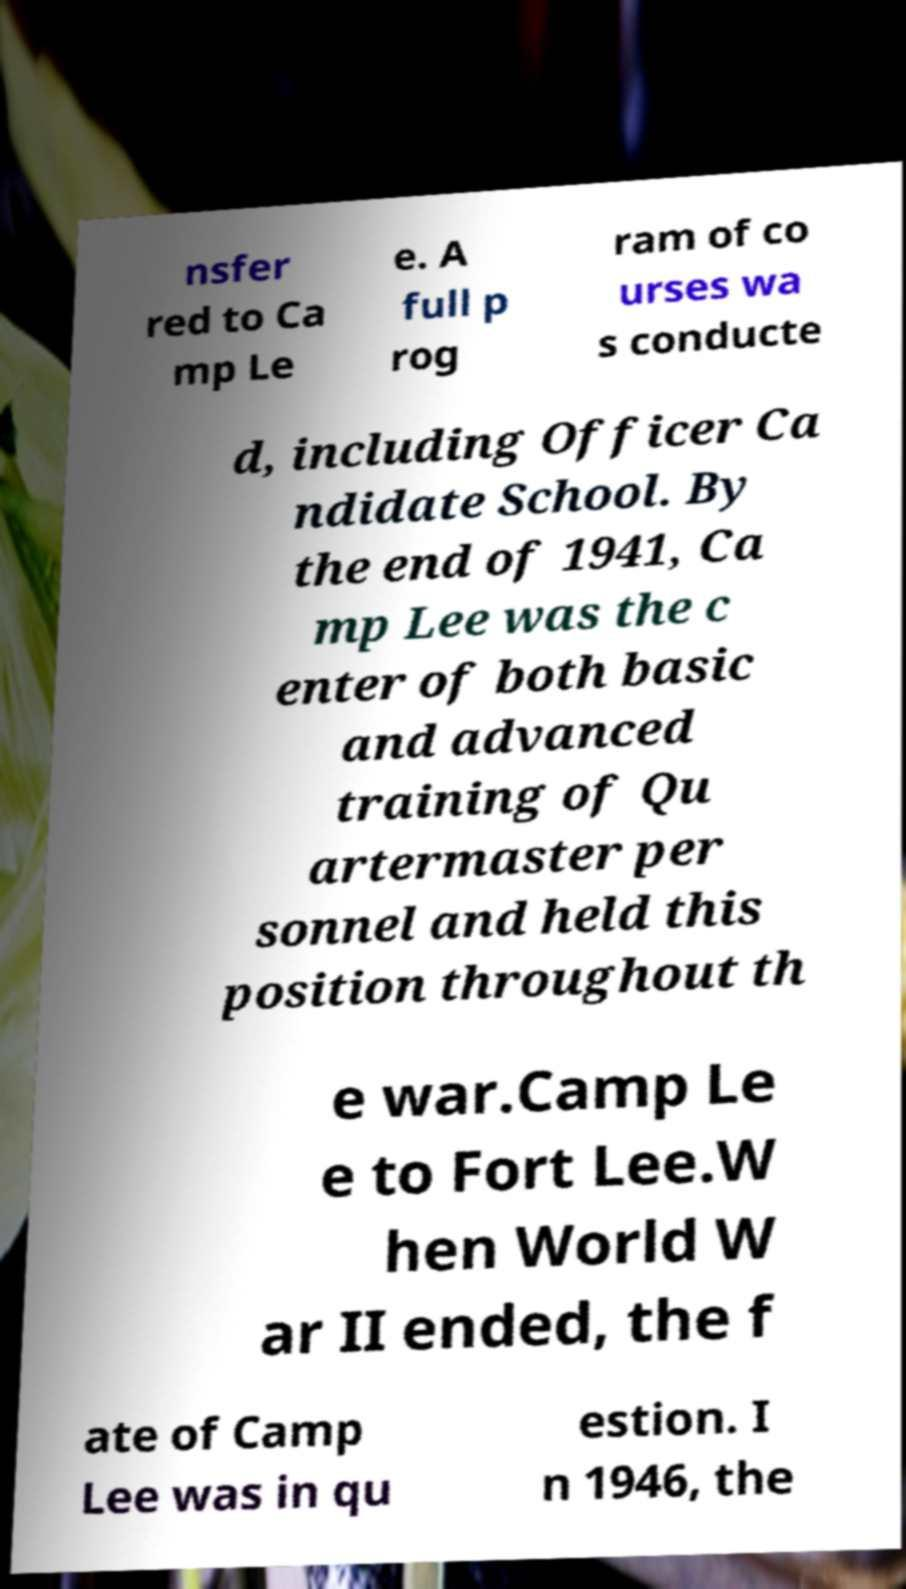Could you assist in decoding the text presented in this image and type it out clearly? nsfer red to Ca mp Le e. A full p rog ram of co urses wa s conducte d, including Officer Ca ndidate School. By the end of 1941, Ca mp Lee was the c enter of both basic and advanced training of Qu artermaster per sonnel and held this position throughout th e war.Camp Le e to Fort Lee.W hen World W ar II ended, the f ate of Camp Lee was in qu estion. I n 1946, the 